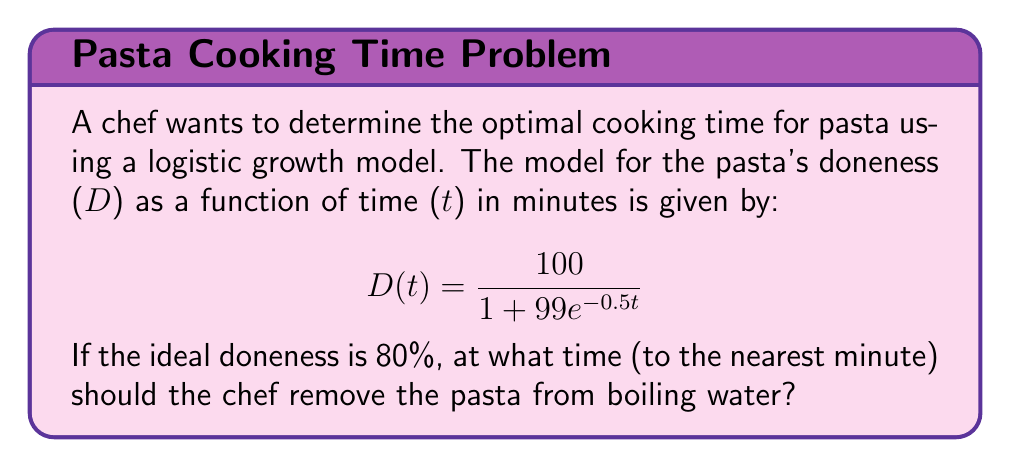Solve this math problem. To solve this problem, we need to follow these steps:

1) The logistic growth model is given by:
   $$D(t) = \frac{100}{1 + 99e^{-0.5t}}$$

2) We want to find t when D(t) = 80. So, we set up the equation:
   $$80 = \frac{100}{1 + 99e^{-0.5t}}$$

3) Multiply both sides by $(1 + 99e^{-0.5t})$:
   $$80(1 + 99e^{-0.5t}) = 100$$

4) Distribute on the left side:
   $$80 + 7920e^{-0.5t} = 100$$

5) Subtract 80 from both sides:
   $$7920e^{-0.5t} = 20$$

6) Divide both sides by 7920:
   $$e^{-0.5t} = \frac{1}{396}$$

7) Take the natural log of both sides:
   $$-0.5t = \ln(\frac{1}{396})$$

8) Multiply both sides by -2:
   $$t = -2\ln(\frac{1}{396})$$

9) Simplify:
   $$t = 2\ln(396) \approx 11.95$$

10) Rounding to the nearest minute:
    $$t \approx 12$$

Therefore, the chef should remove the pasta from boiling water after approximately 12 minutes.
Answer: 12 minutes 